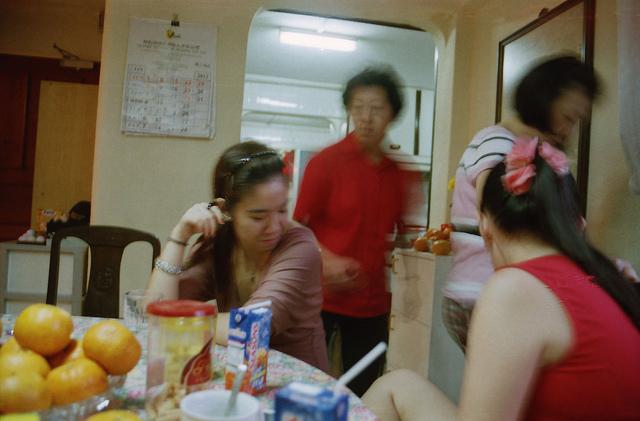How many people in the photo?
Concise answer only. 4. Do the drinks have straws in them?
Keep it brief. Yes. Is this food sweet or sour?
Keep it brief. Sweet. What fruit is she cutting?
Answer briefly. Orange. What is on her head?
Keep it brief. Headband. Is the back of the chair tufted?
Concise answer only. No. Is this woman on a train?
Short answer required. No. What color is the tablecloth?
Concise answer only. Floral. What color is that fruit on the left?
Write a very short answer. Orange. What are the people drinking?
Write a very short answer. Juice. What brand orange juice?
Concise answer only. Nestle. How many women are in the picture?
Concise answer only. 4. How many people are in this picture completely?
Give a very brief answer. 4. Is this woman blowing her nose, caught in food, or trying to hide?
Give a very brief answer. Hide. Could this be her birthday?
Answer briefly. No. What fruit is in the picture?
Answer briefly. Orange. Is the woman a model?
Write a very short answer. No. What food is on the plate?
Write a very short answer. Oranges. Are the people smiling?
Concise answer only. No. What are people drinking?
Be succinct. Juice. Is there a hat on her head?
Quick response, please. No. How many glasses are on the table?
Answer briefly. 1. Are there lemons on this table?
Answer briefly. No. Does the jar lid have a hole in it?
Quick response, please. No. 